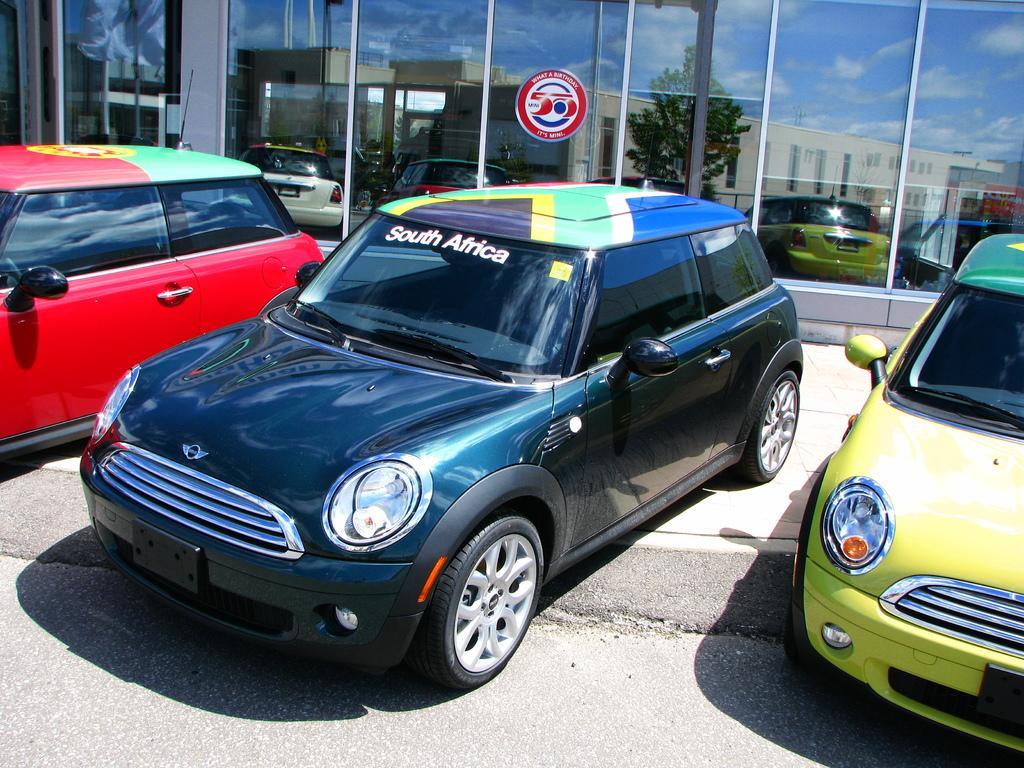Describe this image in one or two sentences. This picture is taken from outside of the city and it is sunny. In this image, on the right side, we can see a car which is in yellow color. On the left side, we can see a car which is in red color. In the middle of the image, we can see a car which is in black color. In the background, we can see a glass window, in the glass window, we can see a building, cars, trees. At the top, we can see a sky which is a bit cloudy, at the bottom, we can see a footpath and a road. 